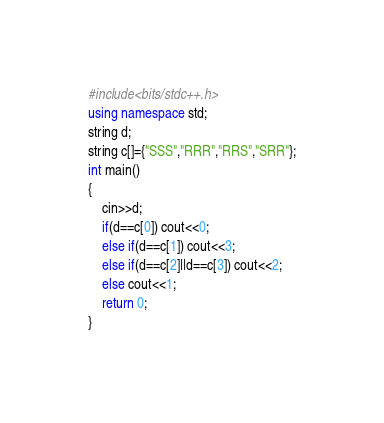<code> <loc_0><loc_0><loc_500><loc_500><_C++_>#include<bits/stdc++.h>
using namespace std;
string d;
string c[]={"SSS","RRR","RRS","SRR"};
int main()
{
	cin>>d;
	if(d==c[0]) cout<<0;
	else if(d==c[1]) cout<<3;
	else if(d==c[2]||d==c[3]) cout<<2;
	else cout<<1;
	return 0;
}</code> 